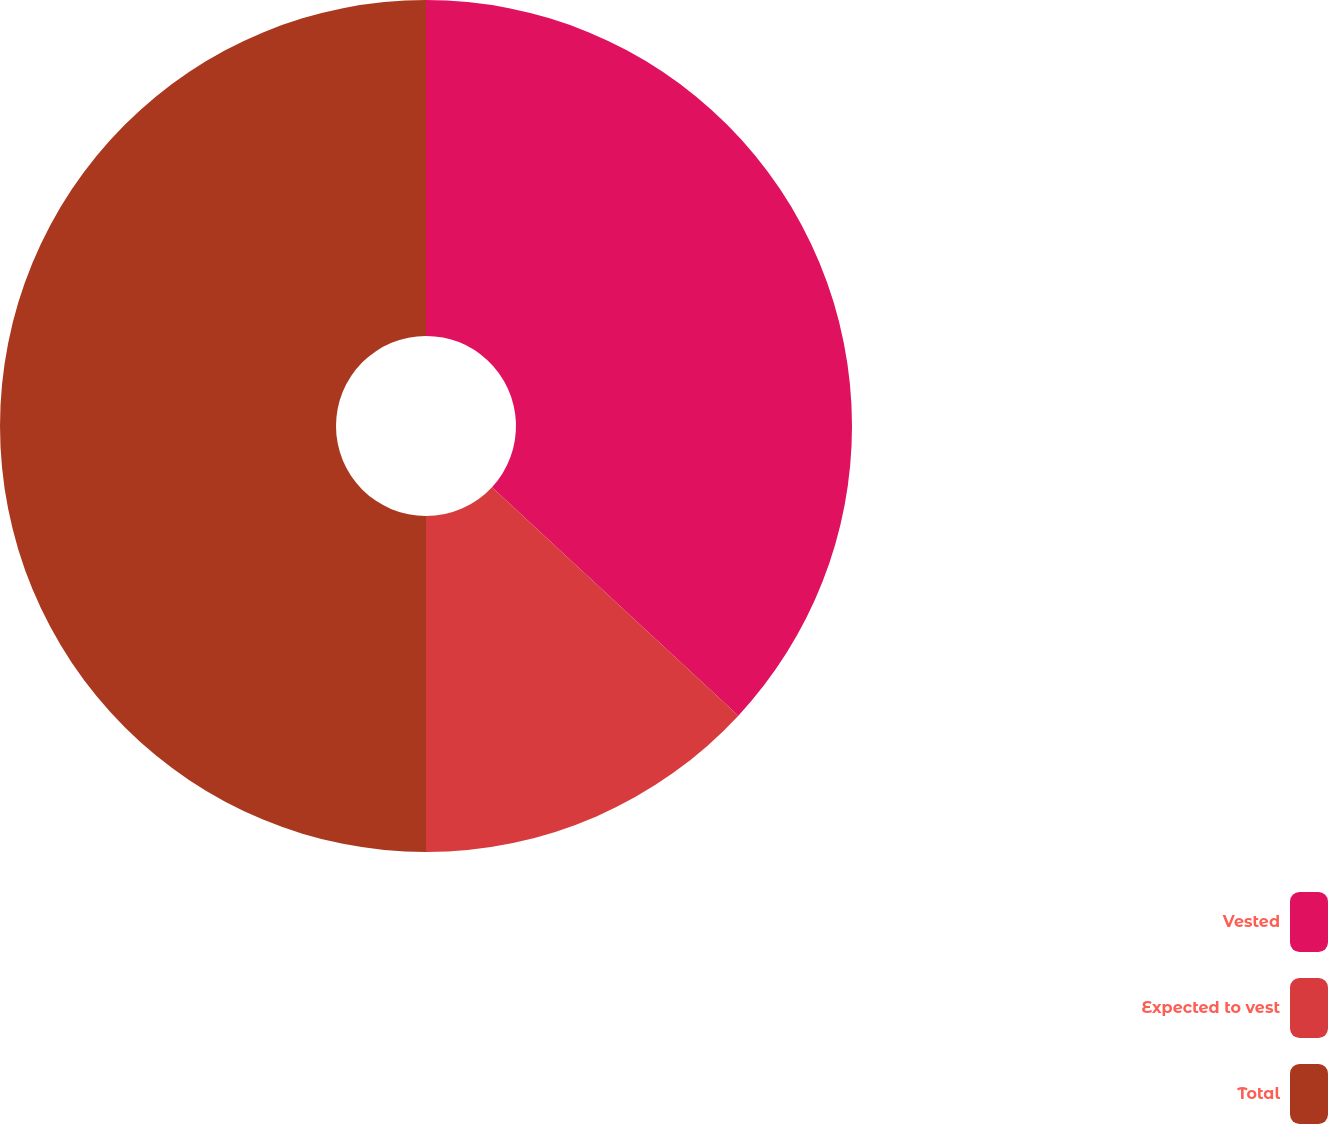Convert chart. <chart><loc_0><loc_0><loc_500><loc_500><pie_chart><fcel>Vested<fcel>Expected to vest<fcel>Total<nl><fcel>36.9%<fcel>13.1%<fcel>50.0%<nl></chart> 